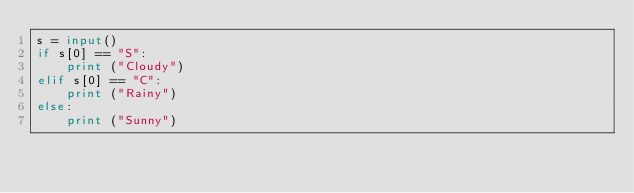<code> <loc_0><loc_0><loc_500><loc_500><_Python_>s = input()
if s[0] == "S":
    print ("Cloudy")
elif s[0] == "C":
    print ("Rainy")
else:
    print ("Sunny")
</code> 